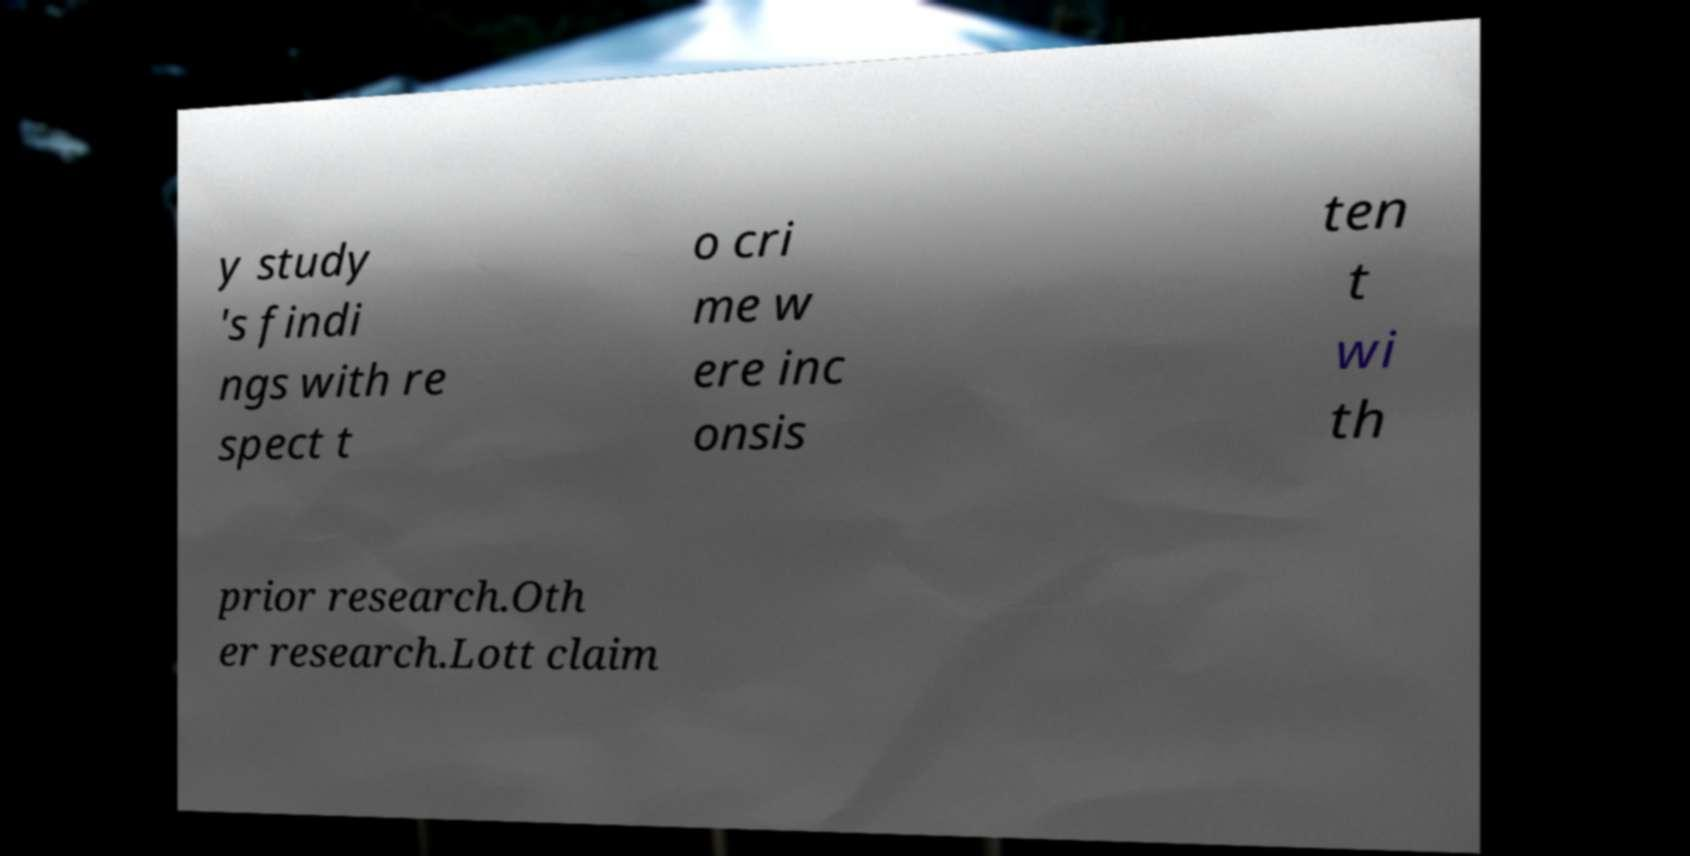There's text embedded in this image that I need extracted. Can you transcribe it verbatim? y study 's findi ngs with re spect t o cri me w ere inc onsis ten t wi th prior research.Oth er research.Lott claim 